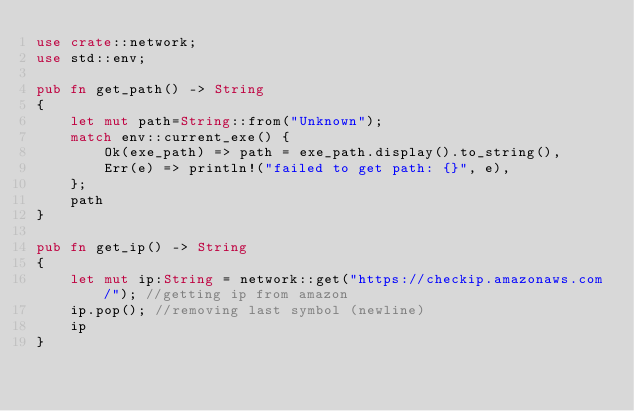<code> <loc_0><loc_0><loc_500><loc_500><_Rust_>use crate::network;
use std::env;

pub fn get_path() -> String
{
	let mut path=String::from("Unknown");
	match env::current_exe() {
		Ok(exe_path) => path = exe_path.display().to_string(),
		Err(e) => println!("failed to get path: {}", e),
	};
	path
}

pub fn get_ip() -> String
{
	let mut ip:String = network::get("https://checkip.amazonaws.com/"); //getting ip from amazon
	ip.pop(); //removing last symbol (newline)
	ip
}
</code> 